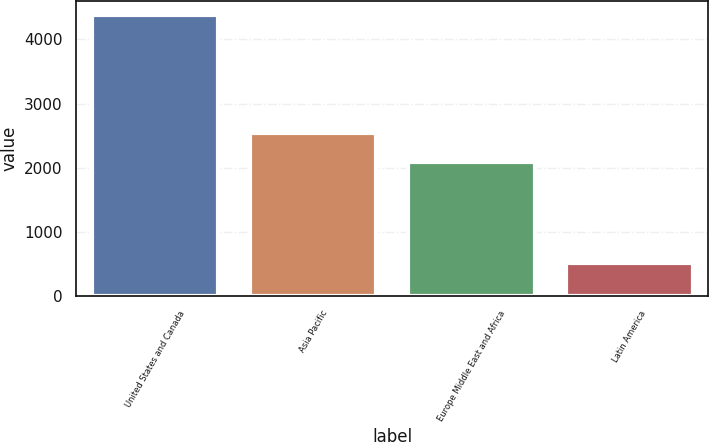Convert chart to OTSL. <chart><loc_0><loc_0><loc_500><loc_500><bar_chart><fcel>United States and Canada<fcel>Asia Pacific<fcel>Europe Middle East and Africa<fcel>Latin America<nl><fcel>4384<fcel>2540<fcel>2091<fcel>512<nl></chart> 